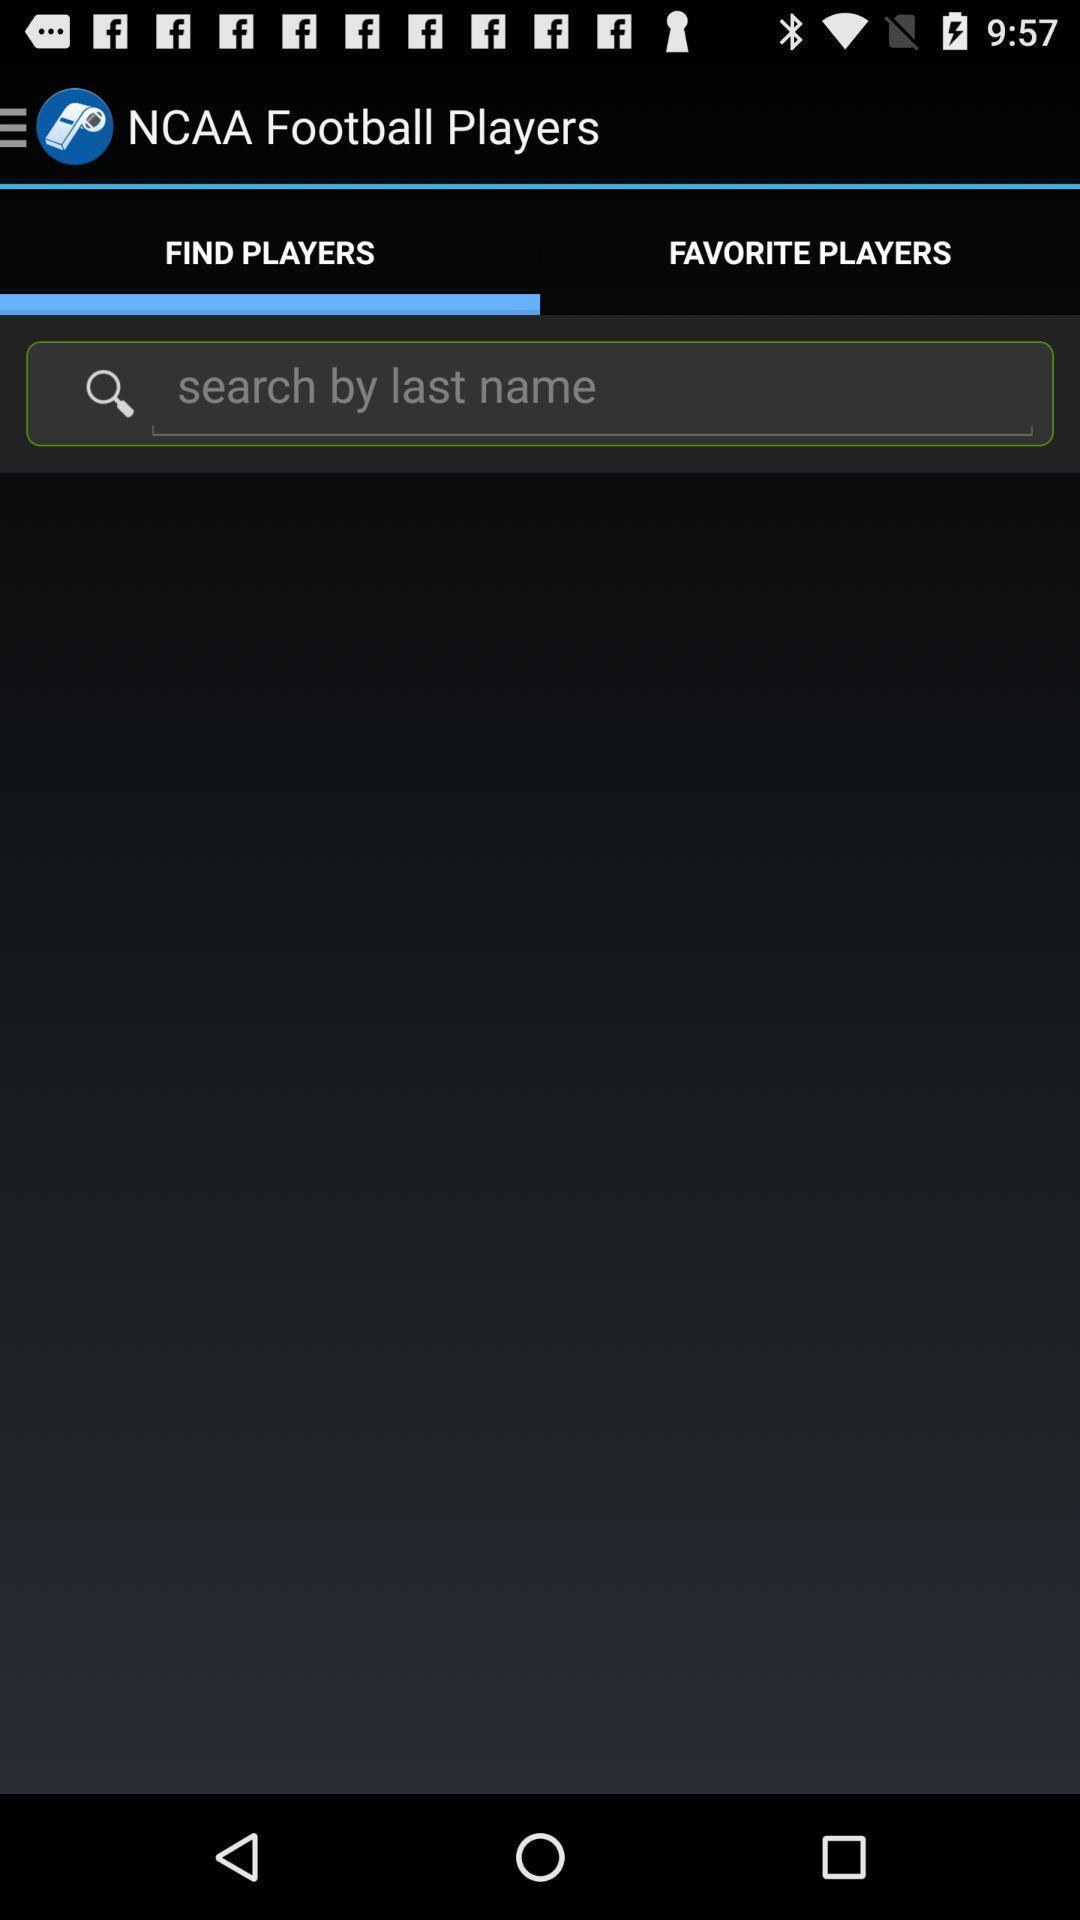Describe the visual elements of this screenshot. Window displaying a sports app. 